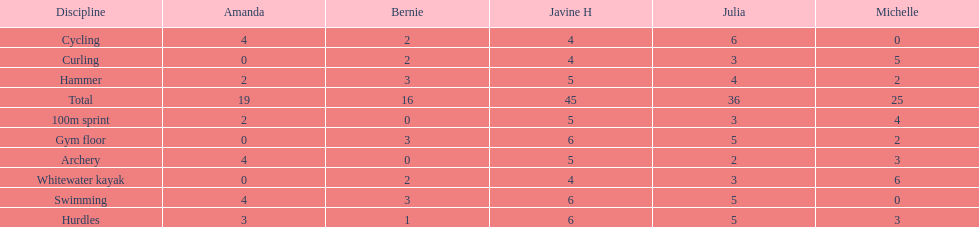Who is the faster runner? Javine H. 